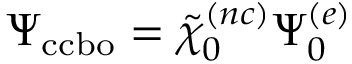<formula> <loc_0><loc_0><loc_500><loc_500>\Psi _ { c c b o } = \tilde { \chi } _ { 0 } ^ { ( n c ) } \Psi _ { 0 } ^ { ( e ) }</formula> 